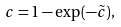<formula> <loc_0><loc_0><loc_500><loc_500>c = 1 - \exp ( - \tilde { c } ) ,</formula> 